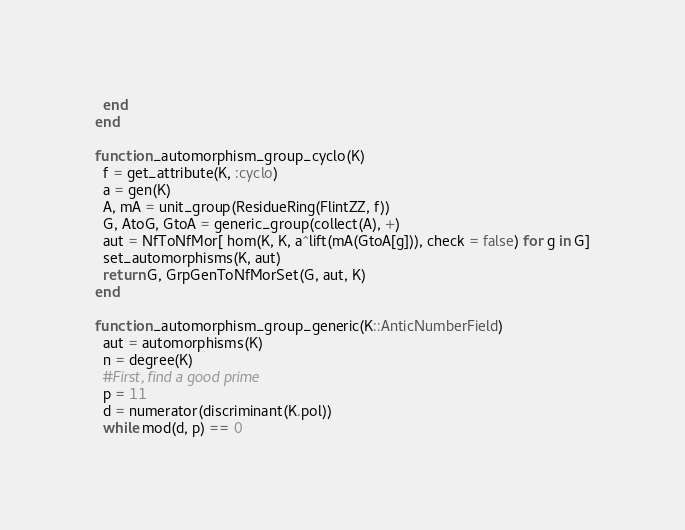<code> <loc_0><loc_0><loc_500><loc_500><_Julia_>  end
end

function _automorphism_group_cyclo(K)
  f = get_attribute(K, :cyclo)
  a = gen(K)
  A, mA = unit_group(ResidueRing(FlintZZ, f))
  G, AtoG, GtoA = generic_group(collect(A), +)
  aut = NfToNfMor[ hom(K, K, a^lift(mA(GtoA[g])), check = false) for g in G]
  set_automorphisms(K, aut)
  return G, GrpGenToNfMorSet(G, aut, K)
end

function _automorphism_group_generic(K::AnticNumberField)
  aut = automorphisms(K)
  n = degree(K)
  #First, find a good prime
  p = 11
  d = numerator(discriminant(K.pol))
  while mod(d, p) == 0</code> 